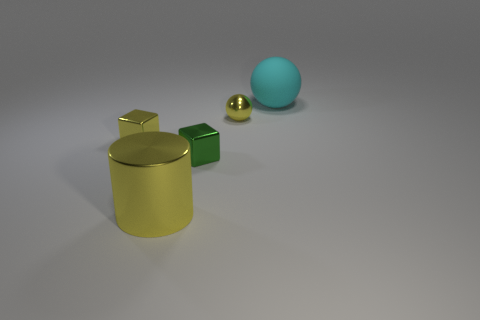What color is the sphere that is the same size as the cylinder?
Provide a succinct answer. Cyan. What number of objects are things that are to the left of the big yellow cylinder or shiny blocks behind the big cylinder?
Provide a succinct answer. 2. Are there the same number of shiny things left of the large yellow metallic cylinder and metal spheres?
Give a very brief answer. Yes. There is a thing that is in front of the green thing; does it have the same size as the yellow thing that is on the left side of the shiny cylinder?
Give a very brief answer. No. What number of other objects are the same size as the yellow cylinder?
Offer a terse response. 1. Is there a yellow metallic sphere on the left side of the tiny cube that is in front of the thing left of the large yellow metal thing?
Your answer should be compact. No. Are there any other things that have the same color as the big shiny cylinder?
Ensure brevity in your answer.  Yes. What is the size of the ball behind the yellow ball?
Ensure brevity in your answer.  Large. There is a yellow thing in front of the cube that is in front of the yellow shiny object to the left of the shiny cylinder; what is its size?
Ensure brevity in your answer.  Large. There is a large thing that is behind the sphere that is in front of the cyan matte thing; what color is it?
Provide a succinct answer. Cyan. 